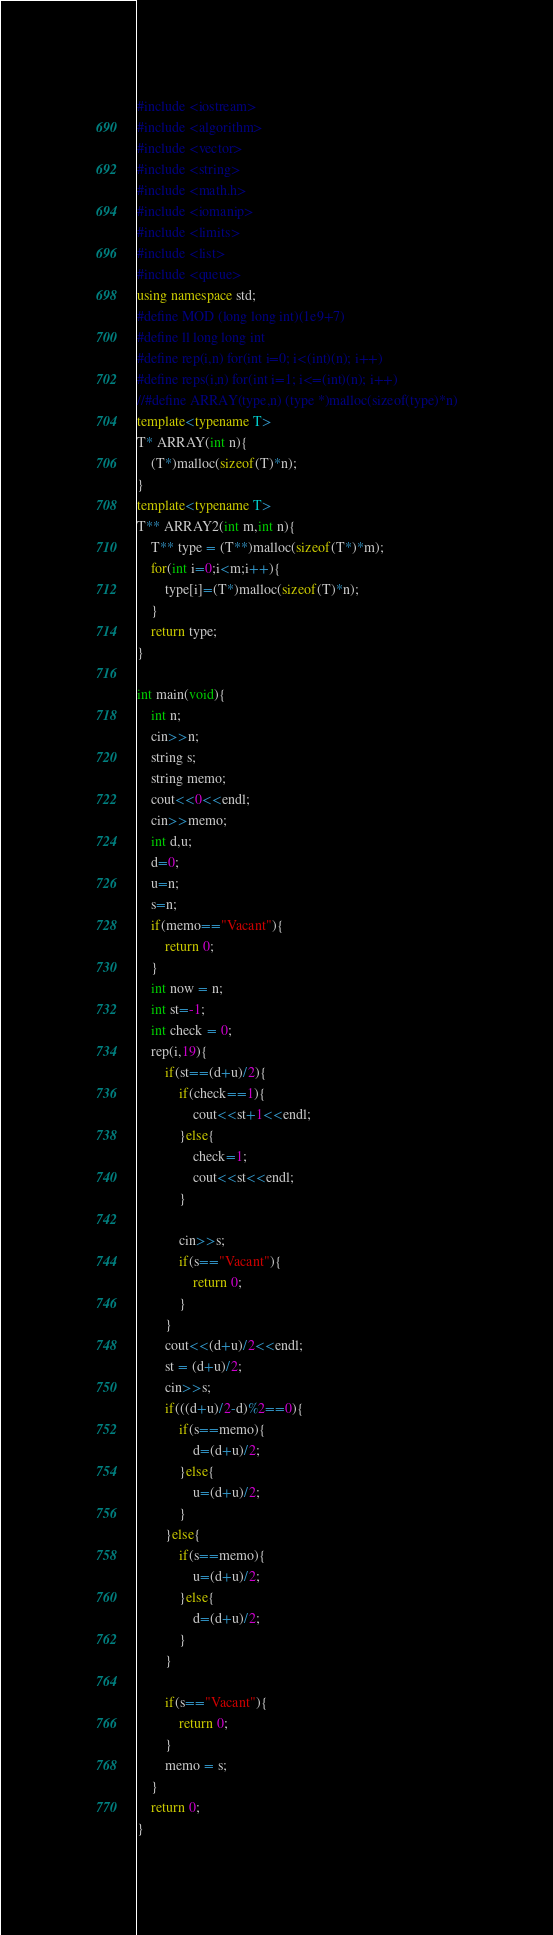Convert code to text. <code><loc_0><loc_0><loc_500><loc_500><_C++_>#include <iostream>
#include <algorithm>
#include <vector>
#include <string>
#include <math.h>
#include <iomanip>
#include <limits>
#include <list>
#include <queue>
using namespace std;
#define MOD (long long int)(1e9+7)
#define ll long long int
#define rep(i,n) for(int i=0; i<(int)(n); i++)
#define reps(i,n) for(int i=1; i<=(int)(n); i++)
//#define ARRAY(type,n) (type *)malloc(sizeof(type)*n)
template<typename T>
T* ARRAY(int n){
	(T*)malloc(sizeof(T)*n);
}
template<typename T>
T** ARRAY2(int m,int n){
	T** type = (T**)malloc(sizeof(T*)*m);
	for(int i=0;i<m;i++){
		type[i]=(T*)malloc(sizeof(T)*n);
	}
	return type;
}

int main(void){
	int n;
	cin>>n;
	string s;
	string memo;
	cout<<0<<endl;
	cin>>memo;
	int d,u;
	d=0;
	u=n;
	s=n;
	if(memo=="Vacant"){
		return 0;
	}
	int now = n;
	int st=-1;
	int check = 0;
	rep(i,19){
		if(st==(d+u)/2){
			if(check==1){
				cout<<st+1<<endl;
			}else{
				check=1;
				cout<<st<<endl;
			}
			
			cin>>s;
			if(s=="Vacant"){
				return 0;
			}
		}
		cout<<(d+u)/2<<endl;
		st = (d+u)/2;
		cin>>s;
		if(((d+u)/2-d)%2==0){
			if(s==memo){
				d=(d+u)/2;
			}else{
				u=(d+u)/2;
			}
		}else{
			if(s==memo){
				u=(d+u)/2;
			}else{
				d=(d+u)/2;
			}
		}

		if(s=="Vacant"){
			return 0;
		}
		memo = s;
	}
	return 0;
}</code> 